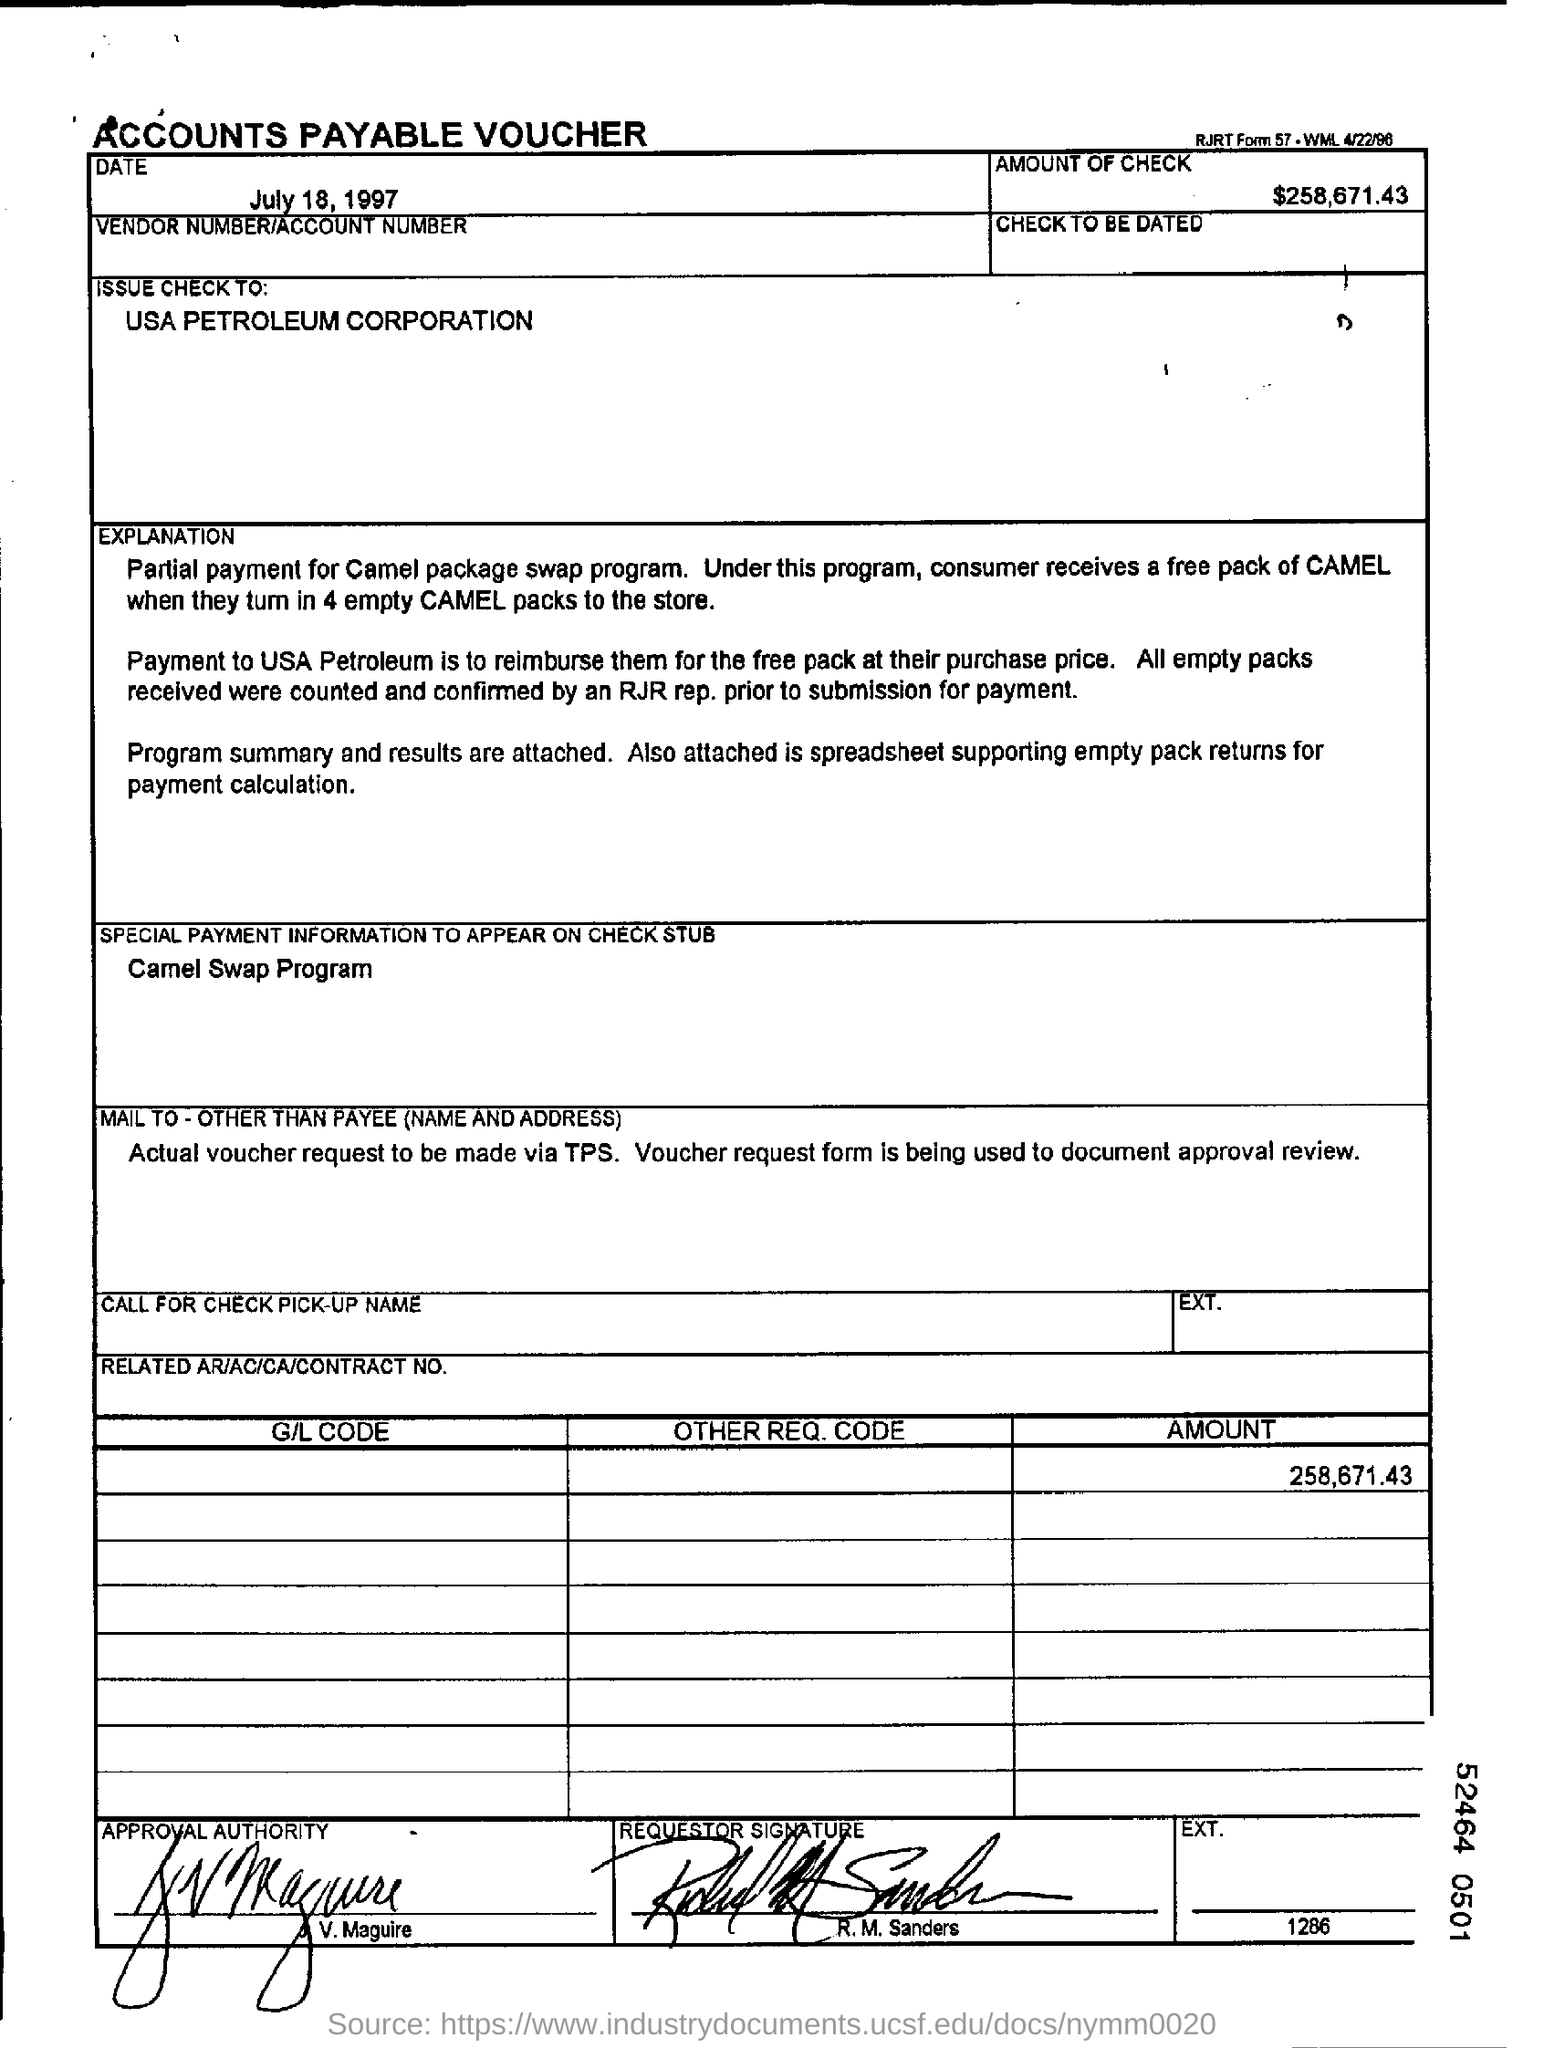To whom, the check is being issued?
Your response must be concise. USA Petroleum corporation. What is the amount of check mentioned in the voucher?
Your response must be concise. $258,671.43. What is the special payment information to appear on check stub?
Provide a short and direct response. Camel swap program. What is the date mentioned in the voucher?
Ensure brevity in your answer.  July 18, 1997. 